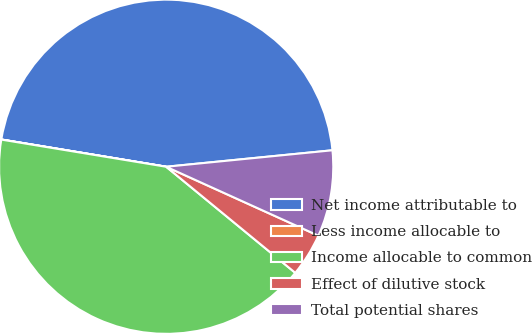<chart> <loc_0><loc_0><loc_500><loc_500><pie_chart><fcel>Net income attributable to<fcel>Less income allocable to<fcel>Income allocable to common<fcel>Effect of dilutive stock<fcel>Total potential shares<nl><fcel>45.82%<fcel>0.01%<fcel>41.65%<fcel>4.18%<fcel>8.34%<nl></chart> 